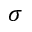<formula> <loc_0><loc_0><loc_500><loc_500>\sigma</formula> 